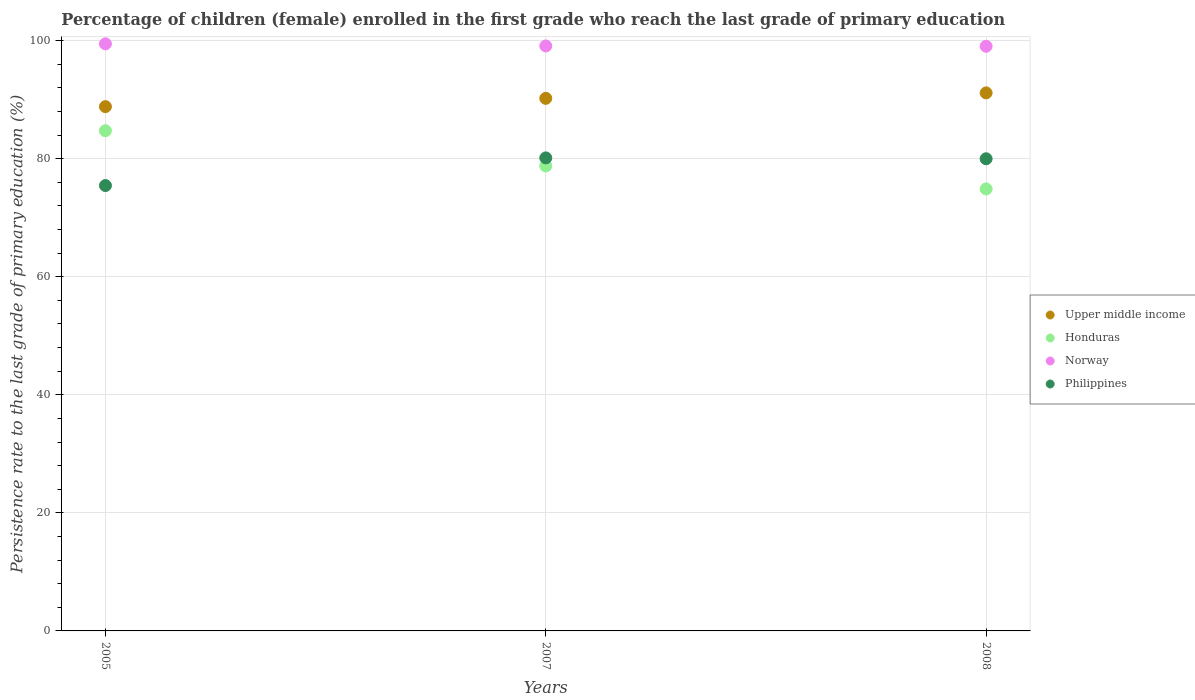How many different coloured dotlines are there?
Your answer should be very brief. 4. Is the number of dotlines equal to the number of legend labels?
Provide a short and direct response. Yes. What is the persistence rate of children in Honduras in 2007?
Offer a terse response. 78.75. Across all years, what is the maximum persistence rate of children in Philippines?
Keep it short and to the point. 80.12. Across all years, what is the minimum persistence rate of children in Norway?
Your response must be concise. 99.03. In which year was the persistence rate of children in Philippines minimum?
Provide a succinct answer. 2005. What is the total persistence rate of children in Norway in the graph?
Offer a very short reply. 297.56. What is the difference between the persistence rate of children in Honduras in 2007 and that in 2008?
Make the answer very short. 3.89. What is the difference between the persistence rate of children in Norway in 2005 and the persistence rate of children in Upper middle income in 2008?
Provide a short and direct response. 8.31. What is the average persistence rate of children in Norway per year?
Make the answer very short. 99.19. In the year 2008, what is the difference between the persistence rate of children in Upper middle income and persistence rate of children in Philippines?
Provide a succinct answer. 11.16. In how many years, is the persistence rate of children in Upper middle income greater than 60 %?
Your response must be concise. 3. What is the ratio of the persistence rate of children in Norway in 2005 to that in 2007?
Keep it short and to the point. 1. Is the difference between the persistence rate of children in Upper middle income in 2005 and 2007 greater than the difference between the persistence rate of children in Philippines in 2005 and 2007?
Offer a terse response. Yes. What is the difference between the highest and the second highest persistence rate of children in Upper middle income?
Give a very brief answer. 0.92. What is the difference between the highest and the lowest persistence rate of children in Norway?
Ensure brevity in your answer.  0.41. In how many years, is the persistence rate of children in Upper middle income greater than the average persistence rate of children in Upper middle income taken over all years?
Give a very brief answer. 2. Is the sum of the persistence rate of children in Norway in 2007 and 2008 greater than the maximum persistence rate of children in Philippines across all years?
Provide a short and direct response. Yes. Is it the case that in every year, the sum of the persistence rate of children in Philippines and persistence rate of children in Honduras  is greater than the persistence rate of children in Upper middle income?
Your answer should be very brief. Yes. Does the persistence rate of children in Norway monotonically increase over the years?
Your answer should be very brief. No. Is the persistence rate of children in Philippines strictly less than the persistence rate of children in Upper middle income over the years?
Offer a very short reply. Yes. Are the values on the major ticks of Y-axis written in scientific E-notation?
Provide a succinct answer. No. Does the graph contain any zero values?
Offer a very short reply. No. Does the graph contain grids?
Ensure brevity in your answer.  Yes. Where does the legend appear in the graph?
Make the answer very short. Center right. How many legend labels are there?
Ensure brevity in your answer.  4. What is the title of the graph?
Provide a succinct answer. Percentage of children (female) enrolled in the first grade who reach the last grade of primary education. What is the label or title of the X-axis?
Your answer should be very brief. Years. What is the label or title of the Y-axis?
Give a very brief answer. Persistence rate to the last grade of primary education (%). What is the Persistence rate to the last grade of primary education (%) of Upper middle income in 2005?
Offer a terse response. 88.81. What is the Persistence rate to the last grade of primary education (%) of Honduras in 2005?
Offer a very short reply. 84.72. What is the Persistence rate to the last grade of primary education (%) in Norway in 2005?
Offer a very short reply. 99.45. What is the Persistence rate to the last grade of primary education (%) of Philippines in 2005?
Give a very brief answer. 75.44. What is the Persistence rate to the last grade of primary education (%) in Upper middle income in 2007?
Give a very brief answer. 90.21. What is the Persistence rate to the last grade of primary education (%) of Honduras in 2007?
Provide a succinct answer. 78.75. What is the Persistence rate to the last grade of primary education (%) of Norway in 2007?
Make the answer very short. 99.09. What is the Persistence rate to the last grade of primary education (%) in Philippines in 2007?
Provide a succinct answer. 80.12. What is the Persistence rate to the last grade of primary education (%) of Upper middle income in 2008?
Your answer should be compact. 91.13. What is the Persistence rate to the last grade of primary education (%) in Honduras in 2008?
Make the answer very short. 74.87. What is the Persistence rate to the last grade of primary education (%) of Norway in 2008?
Ensure brevity in your answer.  99.03. What is the Persistence rate to the last grade of primary education (%) in Philippines in 2008?
Provide a succinct answer. 79.98. Across all years, what is the maximum Persistence rate to the last grade of primary education (%) of Upper middle income?
Keep it short and to the point. 91.13. Across all years, what is the maximum Persistence rate to the last grade of primary education (%) of Honduras?
Your response must be concise. 84.72. Across all years, what is the maximum Persistence rate to the last grade of primary education (%) in Norway?
Keep it short and to the point. 99.45. Across all years, what is the maximum Persistence rate to the last grade of primary education (%) of Philippines?
Provide a short and direct response. 80.12. Across all years, what is the minimum Persistence rate to the last grade of primary education (%) in Upper middle income?
Your response must be concise. 88.81. Across all years, what is the minimum Persistence rate to the last grade of primary education (%) in Honduras?
Provide a short and direct response. 74.87. Across all years, what is the minimum Persistence rate to the last grade of primary education (%) in Norway?
Offer a terse response. 99.03. Across all years, what is the minimum Persistence rate to the last grade of primary education (%) of Philippines?
Your answer should be very brief. 75.44. What is the total Persistence rate to the last grade of primary education (%) of Upper middle income in the graph?
Give a very brief answer. 270.15. What is the total Persistence rate to the last grade of primary education (%) of Honduras in the graph?
Ensure brevity in your answer.  238.35. What is the total Persistence rate to the last grade of primary education (%) of Norway in the graph?
Ensure brevity in your answer.  297.56. What is the total Persistence rate to the last grade of primary education (%) in Philippines in the graph?
Your answer should be very brief. 235.54. What is the difference between the Persistence rate to the last grade of primary education (%) of Upper middle income in 2005 and that in 2007?
Ensure brevity in your answer.  -1.41. What is the difference between the Persistence rate to the last grade of primary education (%) in Honduras in 2005 and that in 2007?
Your answer should be compact. 5.97. What is the difference between the Persistence rate to the last grade of primary education (%) of Norway in 2005 and that in 2007?
Your response must be concise. 0.36. What is the difference between the Persistence rate to the last grade of primary education (%) in Philippines in 2005 and that in 2007?
Your answer should be very brief. -4.68. What is the difference between the Persistence rate to the last grade of primary education (%) in Upper middle income in 2005 and that in 2008?
Make the answer very short. -2.33. What is the difference between the Persistence rate to the last grade of primary education (%) of Honduras in 2005 and that in 2008?
Make the answer very short. 9.86. What is the difference between the Persistence rate to the last grade of primary education (%) of Norway in 2005 and that in 2008?
Make the answer very short. 0.41. What is the difference between the Persistence rate to the last grade of primary education (%) in Philippines in 2005 and that in 2008?
Offer a terse response. -4.54. What is the difference between the Persistence rate to the last grade of primary education (%) of Upper middle income in 2007 and that in 2008?
Your answer should be very brief. -0.92. What is the difference between the Persistence rate to the last grade of primary education (%) of Honduras in 2007 and that in 2008?
Provide a succinct answer. 3.89. What is the difference between the Persistence rate to the last grade of primary education (%) in Norway in 2007 and that in 2008?
Your response must be concise. 0.05. What is the difference between the Persistence rate to the last grade of primary education (%) of Philippines in 2007 and that in 2008?
Keep it short and to the point. 0.15. What is the difference between the Persistence rate to the last grade of primary education (%) of Upper middle income in 2005 and the Persistence rate to the last grade of primary education (%) of Honduras in 2007?
Keep it short and to the point. 10.05. What is the difference between the Persistence rate to the last grade of primary education (%) of Upper middle income in 2005 and the Persistence rate to the last grade of primary education (%) of Norway in 2007?
Ensure brevity in your answer.  -10.28. What is the difference between the Persistence rate to the last grade of primary education (%) of Upper middle income in 2005 and the Persistence rate to the last grade of primary education (%) of Philippines in 2007?
Make the answer very short. 8.68. What is the difference between the Persistence rate to the last grade of primary education (%) of Honduras in 2005 and the Persistence rate to the last grade of primary education (%) of Norway in 2007?
Provide a succinct answer. -14.36. What is the difference between the Persistence rate to the last grade of primary education (%) of Honduras in 2005 and the Persistence rate to the last grade of primary education (%) of Philippines in 2007?
Ensure brevity in your answer.  4.6. What is the difference between the Persistence rate to the last grade of primary education (%) of Norway in 2005 and the Persistence rate to the last grade of primary education (%) of Philippines in 2007?
Give a very brief answer. 19.32. What is the difference between the Persistence rate to the last grade of primary education (%) in Upper middle income in 2005 and the Persistence rate to the last grade of primary education (%) in Honduras in 2008?
Your response must be concise. 13.94. What is the difference between the Persistence rate to the last grade of primary education (%) of Upper middle income in 2005 and the Persistence rate to the last grade of primary education (%) of Norway in 2008?
Your answer should be very brief. -10.23. What is the difference between the Persistence rate to the last grade of primary education (%) in Upper middle income in 2005 and the Persistence rate to the last grade of primary education (%) in Philippines in 2008?
Offer a terse response. 8.83. What is the difference between the Persistence rate to the last grade of primary education (%) of Honduras in 2005 and the Persistence rate to the last grade of primary education (%) of Norway in 2008?
Ensure brevity in your answer.  -14.31. What is the difference between the Persistence rate to the last grade of primary education (%) of Honduras in 2005 and the Persistence rate to the last grade of primary education (%) of Philippines in 2008?
Offer a terse response. 4.75. What is the difference between the Persistence rate to the last grade of primary education (%) in Norway in 2005 and the Persistence rate to the last grade of primary education (%) in Philippines in 2008?
Offer a very short reply. 19.47. What is the difference between the Persistence rate to the last grade of primary education (%) of Upper middle income in 2007 and the Persistence rate to the last grade of primary education (%) of Honduras in 2008?
Offer a terse response. 15.34. What is the difference between the Persistence rate to the last grade of primary education (%) of Upper middle income in 2007 and the Persistence rate to the last grade of primary education (%) of Norway in 2008?
Keep it short and to the point. -8.82. What is the difference between the Persistence rate to the last grade of primary education (%) of Upper middle income in 2007 and the Persistence rate to the last grade of primary education (%) of Philippines in 2008?
Make the answer very short. 10.24. What is the difference between the Persistence rate to the last grade of primary education (%) of Honduras in 2007 and the Persistence rate to the last grade of primary education (%) of Norway in 2008?
Give a very brief answer. -20.28. What is the difference between the Persistence rate to the last grade of primary education (%) in Honduras in 2007 and the Persistence rate to the last grade of primary education (%) in Philippines in 2008?
Make the answer very short. -1.22. What is the difference between the Persistence rate to the last grade of primary education (%) of Norway in 2007 and the Persistence rate to the last grade of primary education (%) of Philippines in 2008?
Your answer should be very brief. 19.11. What is the average Persistence rate to the last grade of primary education (%) in Upper middle income per year?
Your answer should be very brief. 90.05. What is the average Persistence rate to the last grade of primary education (%) in Honduras per year?
Offer a very short reply. 79.45. What is the average Persistence rate to the last grade of primary education (%) in Norway per year?
Your answer should be very brief. 99.19. What is the average Persistence rate to the last grade of primary education (%) of Philippines per year?
Keep it short and to the point. 78.51. In the year 2005, what is the difference between the Persistence rate to the last grade of primary education (%) of Upper middle income and Persistence rate to the last grade of primary education (%) of Honduras?
Your answer should be compact. 4.08. In the year 2005, what is the difference between the Persistence rate to the last grade of primary education (%) of Upper middle income and Persistence rate to the last grade of primary education (%) of Norway?
Ensure brevity in your answer.  -10.64. In the year 2005, what is the difference between the Persistence rate to the last grade of primary education (%) in Upper middle income and Persistence rate to the last grade of primary education (%) in Philippines?
Keep it short and to the point. 13.37. In the year 2005, what is the difference between the Persistence rate to the last grade of primary education (%) of Honduras and Persistence rate to the last grade of primary education (%) of Norway?
Offer a terse response. -14.72. In the year 2005, what is the difference between the Persistence rate to the last grade of primary education (%) in Honduras and Persistence rate to the last grade of primary education (%) in Philippines?
Make the answer very short. 9.28. In the year 2005, what is the difference between the Persistence rate to the last grade of primary education (%) in Norway and Persistence rate to the last grade of primary education (%) in Philippines?
Provide a succinct answer. 24.01. In the year 2007, what is the difference between the Persistence rate to the last grade of primary education (%) in Upper middle income and Persistence rate to the last grade of primary education (%) in Honduras?
Provide a succinct answer. 11.46. In the year 2007, what is the difference between the Persistence rate to the last grade of primary education (%) of Upper middle income and Persistence rate to the last grade of primary education (%) of Norway?
Provide a succinct answer. -8.87. In the year 2007, what is the difference between the Persistence rate to the last grade of primary education (%) of Upper middle income and Persistence rate to the last grade of primary education (%) of Philippines?
Offer a very short reply. 10.09. In the year 2007, what is the difference between the Persistence rate to the last grade of primary education (%) of Honduras and Persistence rate to the last grade of primary education (%) of Norway?
Ensure brevity in your answer.  -20.33. In the year 2007, what is the difference between the Persistence rate to the last grade of primary education (%) in Honduras and Persistence rate to the last grade of primary education (%) in Philippines?
Ensure brevity in your answer.  -1.37. In the year 2007, what is the difference between the Persistence rate to the last grade of primary education (%) of Norway and Persistence rate to the last grade of primary education (%) of Philippines?
Provide a succinct answer. 18.96. In the year 2008, what is the difference between the Persistence rate to the last grade of primary education (%) in Upper middle income and Persistence rate to the last grade of primary education (%) in Honduras?
Your answer should be very brief. 16.27. In the year 2008, what is the difference between the Persistence rate to the last grade of primary education (%) in Upper middle income and Persistence rate to the last grade of primary education (%) in Norway?
Offer a very short reply. -7.9. In the year 2008, what is the difference between the Persistence rate to the last grade of primary education (%) of Upper middle income and Persistence rate to the last grade of primary education (%) of Philippines?
Give a very brief answer. 11.16. In the year 2008, what is the difference between the Persistence rate to the last grade of primary education (%) in Honduras and Persistence rate to the last grade of primary education (%) in Norway?
Offer a terse response. -24.16. In the year 2008, what is the difference between the Persistence rate to the last grade of primary education (%) in Honduras and Persistence rate to the last grade of primary education (%) in Philippines?
Offer a terse response. -5.11. In the year 2008, what is the difference between the Persistence rate to the last grade of primary education (%) of Norway and Persistence rate to the last grade of primary education (%) of Philippines?
Offer a terse response. 19.06. What is the ratio of the Persistence rate to the last grade of primary education (%) of Upper middle income in 2005 to that in 2007?
Ensure brevity in your answer.  0.98. What is the ratio of the Persistence rate to the last grade of primary education (%) in Honduras in 2005 to that in 2007?
Provide a short and direct response. 1.08. What is the ratio of the Persistence rate to the last grade of primary education (%) of Philippines in 2005 to that in 2007?
Ensure brevity in your answer.  0.94. What is the ratio of the Persistence rate to the last grade of primary education (%) of Upper middle income in 2005 to that in 2008?
Your answer should be very brief. 0.97. What is the ratio of the Persistence rate to the last grade of primary education (%) in Honduras in 2005 to that in 2008?
Your answer should be compact. 1.13. What is the ratio of the Persistence rate to the last grade of primary education (%) of Norway in 2005 to that in 2008?
Provide a succinct answer. 1. What is the ratio of the Persistence rate to the last grade of primary education (%) in Philippines in 2005 to that in 2008?
Offer a terse response. 0.94. What is the ratio of the Persistence rate to the last grade of primary education (%) of Upper middle income in 2007 to that in 2008?
Keep it short and to the point. 0.99. What is the ratio of the Persistence rate to the last grade of primary education (%) in Honduras in 2007 to that in 2008?
Give a very brief answer. 1.05. What is the ratio of the Persistence rate to the last grade of primary education (%) of Philippines in 2007 to that in 2008?
Your response must be concise. 1. What is the difference between the highest and the second highest Persistence rate to the last grade of primary education (%) in Upper middle income?
Make the answer very short. 0.92. What is the difference between the highest and the second highest Persistence rate to the last grade of primary education (%) in Honduras?
Provide a short and direct response. 5.97. What is the difference between the highest and the second highest Persistence rate to the last grade of primary education (%) in Norway?
Offer a very short reply. 0.36. What is the difference between the highest and the second highest Persistence rate to the last grade of primary education (%) in Philippines?
Offer a terse response. 0.15. What is the difference between the highest and the lowest Persistence rate to the last grade of primary education (%) of Upper middle income?
Your answer should be very brief. 2.33. What is the difference between the highest and the lowest Persistence rate to the last grade of primary education (%) in Honduras?
Your response must be concise. 9.86. What is the difference between the highest and the lowest Persistence rate to the last grade of primary education (%) in Norway?
Give a very brief answer. 0.41. What is the difference between the highest and the lowest Persistence rate to the last grade of primary education (%) in Philippines?
Offer a terse response. 4.68. 